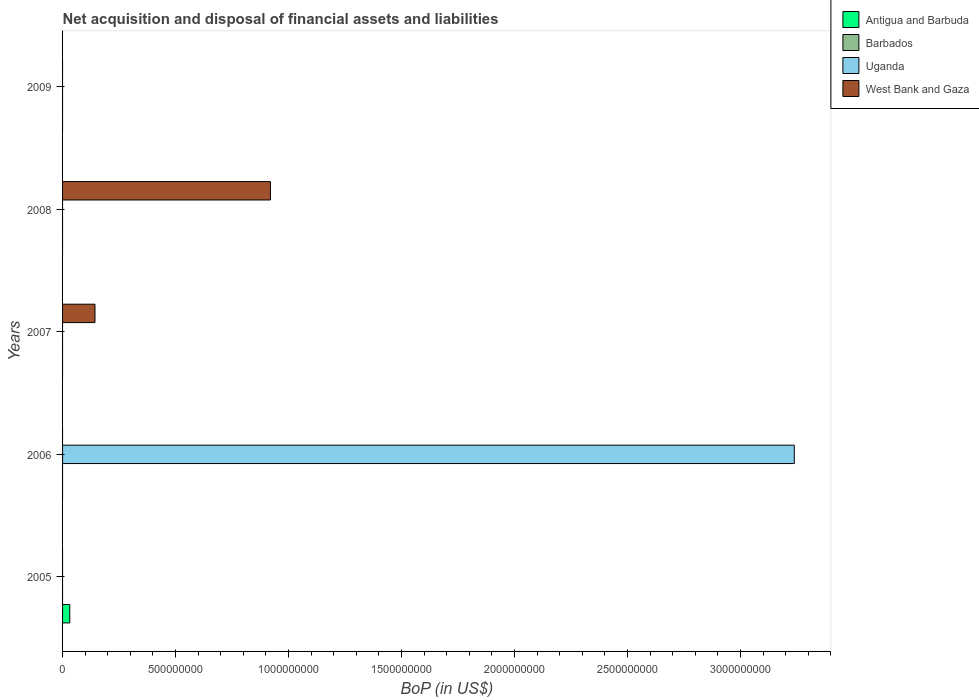How many bars are there on the 3rd tick from the top?
Keep it short and to the point. 1. What is the label of the 3rd group of bars from the top?
Your answer should be very brief. 2007. In how many cases, is the number of bars for a given year not equal to the number of legend labels?
Your answer should be very brief. 5. Across all years, what is the maximum Balance of Payments in West Bank and Gaza?
Offer a terse response. 9.20e+08. What is the total Balance of Payments in West Bank and Gaza in the graph?
Your response must be concise. 1.06e+09. What is the difference between the Balance of Payments in Barbados in 2006 and the Balance of Payments in Antigua and Barbuda in 2007?
Provide a succinct answer. 0. What is the average Balance of Payments in Uganda per year?
Your answer should be compact. 6.48e+08. What is the difference between the highest and the lowest Balance of Payments in Antigua and Barbuda?
Make the answer very short. 3.18e+07. In how many years, is the Balance of Payments in Antigua and Barbuda greater than the average Balance of Payments in Antigua and Barbuda taken over all years?
Your answer should be compact. 1. How many bars are there?
Offer a terse response. 4. Are all the bars in the graph horizontal?
Your answer should be very brief. Yes. What is the title of the graph?
Make the answer very short. Net acquisition and disposal of financial assets and liabilities. What is the label or title of the X-axis?
Ensure brevity in your answer.  BoP (in US$). What is the label or title of the Y-axis?
Your answer should be compact. Years. What is the BoP (in US$) of Antigua and Barbuda in 2005?
Provide a succinct answer. 3.18e+07. What is the BoP (in US$) of Uganda in 2005?
Your answer should be very brief. 0. What is the BoP (in US$) of West Bank and Gaza in 2005?
Your answer should be compact. 0. What is the BoP (in US$) of Antigua and Barbuda in 2006?
Keep it short and to the point. 0. What is the BoP (in US$) of Barbados in 2006?
Keep it short and to the point. 0. What is the BoP (in US$) of Uganda in 2006?
Give a very brief answer. 3.24e+09. What is the BoP (in US$) of Antigua and Barbuda in 2007?
Keep it short and to the point. 0. What is the BoP (in US$) of Barbados in 2007?
Keep it short and to the point. 0. What is the BoP (in US$) in West Bank and Gaza in 2007?
Give a very brief answer. 1.43e+08. What is the BoP (in US$) of Antigua and Barbuda in 2008?
Provide a short and direct response. 0. What is the BoP (in US$) in West Bank and Gaza in 2008?
Offer a terse response. 9.20e+08. What is the BoP (in US$) in Uganda in 2009?
Offer a terse response. 0. Across all years, what is the maximum BoP (in US$) in Antigua and Barbuda?
Provide a short and direct response. 3.18e+07. Across all years, what is the maximum BoP (in US$) of Uganda?
Ensure brevity in your answer.  3.24e+09. Across all years, what is the maximum BoP (in US$) in West Bank and Gaza?
Offer a very short reply. 9.20e+08. Across all years, what is the minimum BoP (in US$) of Antigua and Barbuda?
Your response must be concise. 0. What is the total BoP (in US$) in Antigua and Barbuda in the graph?
Ensure brevity in your answer.  3.18e+07. What is the total BoP (in US$) of Uganda in the graph?
Give a very brief answer. 3.24e+09. What is the total BoP (in US$) in West Bank and Gaza in the graph?
Offer a very short reply. 1.06e+09. What is the difference between the BoP (in US$) of West Bank and Gaza in 2007 and that in 2008?
Provide a short and direct response. -7.76e+08. What is the difference between the BoP (in US$) in Antigua and Barbuda in 2005 and the BoP (in US$) in Uganda in 2006?
Your response must be concise. -3.21e+09. What is the difference between the BoP (in US$) of Antigua and Barbuda in 2005 and the BoP (in US$) of West Bank and Gaza in 2007?
Your answer should be very brief. -1.12e+08. What is the difference between the BoP (in US$) of Antigua and Barbuda in 2005 and the BoP (in US$) of West Bank and Gaza in 2008?
Your answer should be compact. -8.88e+08. What is the difference between the BoP (in US$) of Uganda in 2006 and the BoP (in US$) of West Bank and Gaza in 2007?
Provide a succinct answer. 3.10e+09. What is the difference between the BoP (in US$) of Uganda in 2006 and the BoP (in US$) of West Bank and Gaza in 2008?
Your answer should be very brief. 2.32e+09. What is the average BoP (in US$) in Antigua and Barbuda per year?
Give a very brief answer. 6.35e+06. What is the average BoP (in US$) of Uganda per year?
Keep it short and to the point. 6.48e+08. What is the average BoP (in US$) in West Bank and Gaza per year?
Offer a very short reply. 2.13e+08. What is the ratio of the BoP (in US$) in West Bank and Gaza in 2007 to that in 2008?
Provide a short and direct response. 0.16. What is the difference between the highest and the lowest BoP (in US$) in Antigua and Barbuda?
Provide a succinct answer. 3.18e+07. What is the difference between the highest and the lowest BoP (in US$) of Uganda?
Your answer should be very brief. 3.24e+09. What is the difference between the highest and the lowest BoP (in US$) of West Bank and Gaza?
Ensure brevity in your answer.  9.20e+08. 